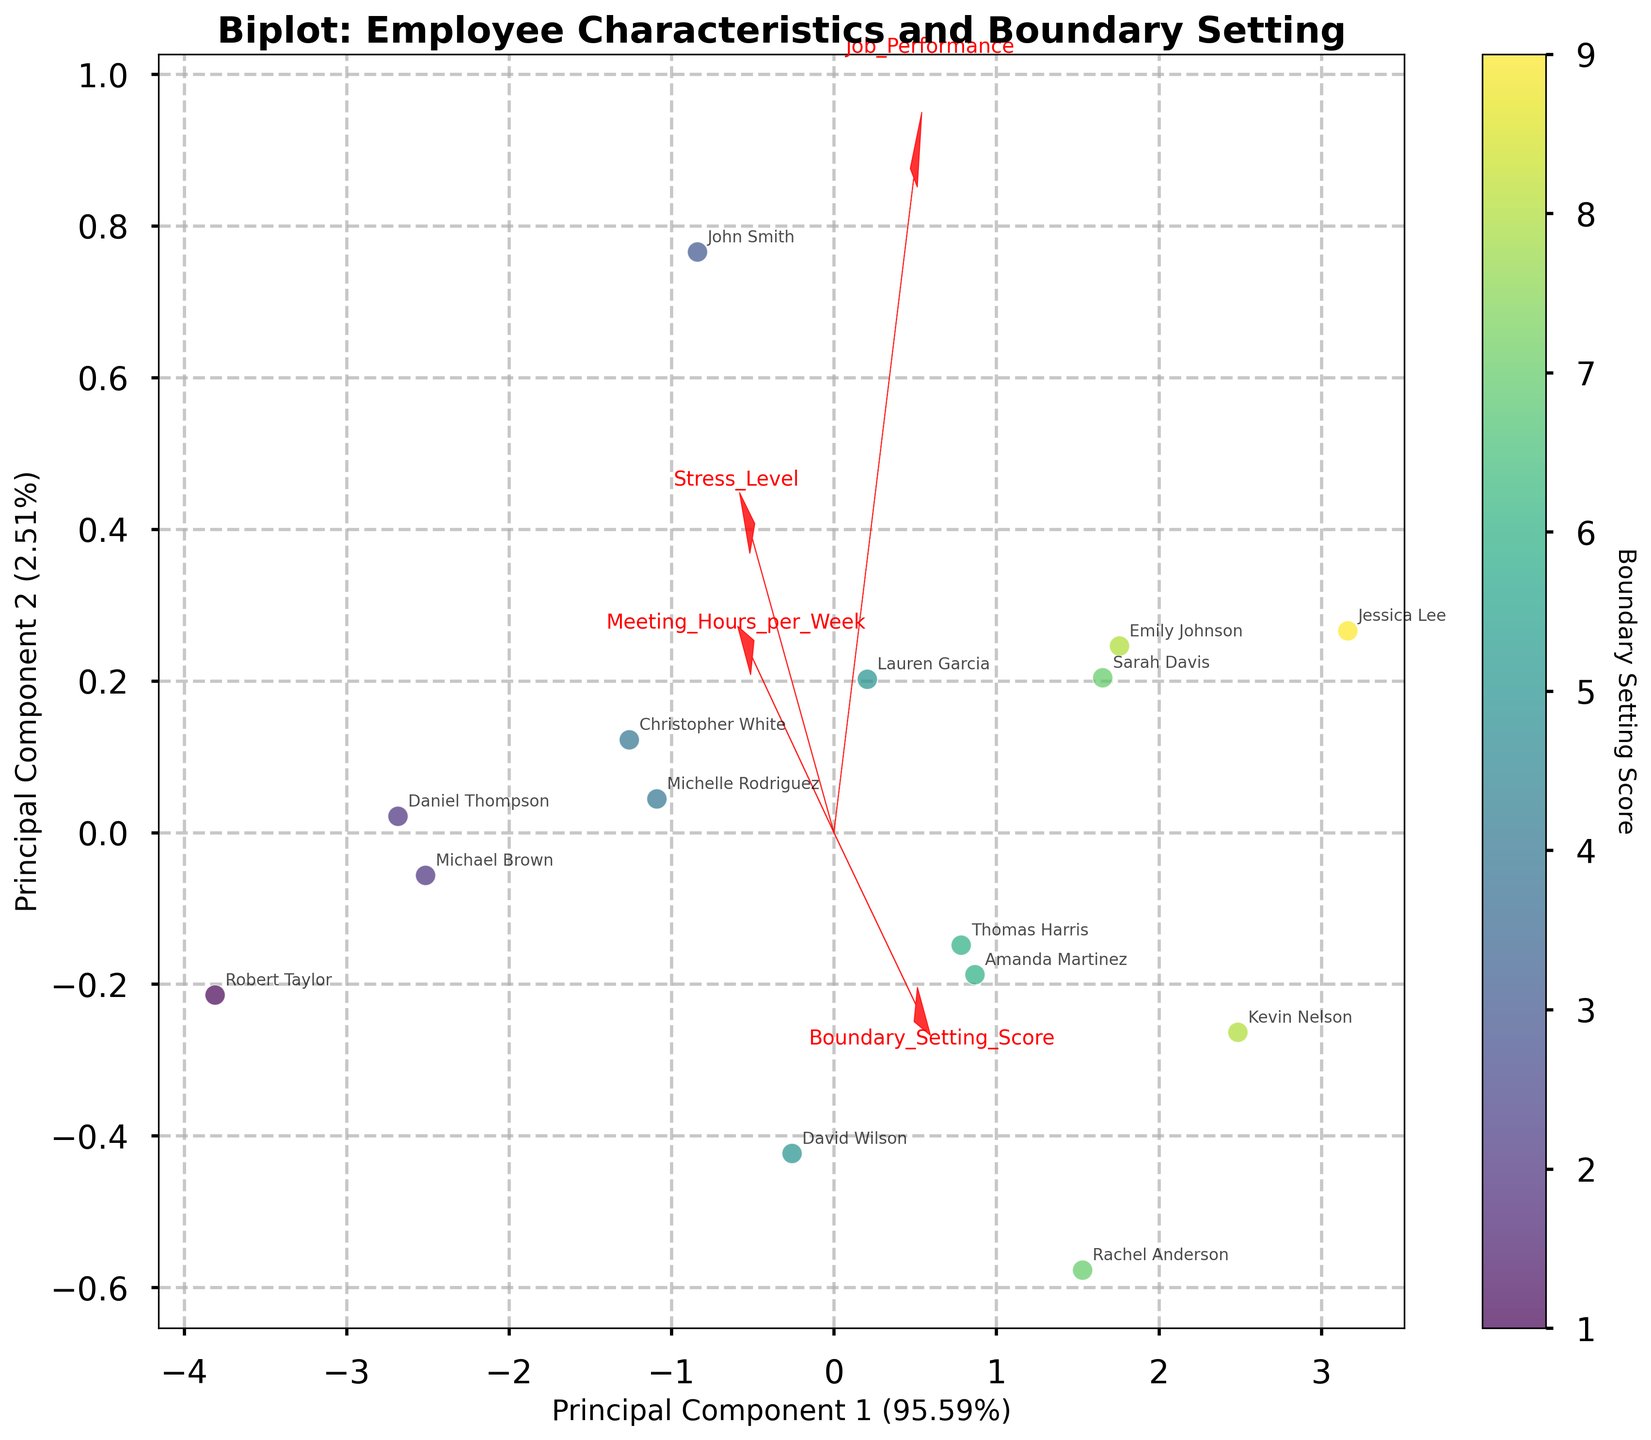How many employees are represented in the biplot? Count the number of data points (each representing an employee) in the plot.
Answer: 15 Which axis represents the principal component with the highest explained variance? The x-axis is labeled 'Principal Component 1', and the percentage explained by each component is displayed in the labels. Compare the percentages; the higher value indicates the axis representing the principal component with the most explained variance.
Answer: x-axis What is the relationship between Meeting Hours per Week and Boundary Setting Score indicated by the arrows? Identify the orientations and directions of the arrows representing Meeting Hours per Week and Boundary Setting Score. If the arrows point in opposite directions, there's a negative correlation; if they point in similar directions, there's a positive correlation.
Answer: Negative correlation Which employee has the lowest Boundary Setting Score and how is this reflected in their position on the biplot? Locate the data point with the lowest Boundary Setting Score as indicated by the color bar, and identify the employee associated with it. Note their position relative to the principal components.
Answer: Robert Taylor, positioned toward the lower left Compare the stress level of employees with high Boundary Setting Scores to those with low Boundary Setting Scores based on their positions on the biplot. Identify data points with high Boundary Setting Scores and compare their stress level values to those with low Boundary Setting Scores, considering their placement on the biplot.
Answer: High scores tend to have lower stress levels What feature vectors are closest to Principal Component 1? Look at the feature vectors represented by arrows and see which ones are most aligned with the x-axis.
Answer: Stress Level, Meeting Hours per Week Is there a notable trend between Job Performance and Meeting Hours per Week from the arrows? Compare the direction of the arrows representing Job Performance and Meeting Hours per Week to identify if they show a positive or negative correlation. Note the angle between them.
Answer: Negative trend Which employee has the closest alignment with the vector representing Job Performance? Observe the direction of the Job Performance arrow and identify the data point closest to that direction.
Answer: Jessica Lee 